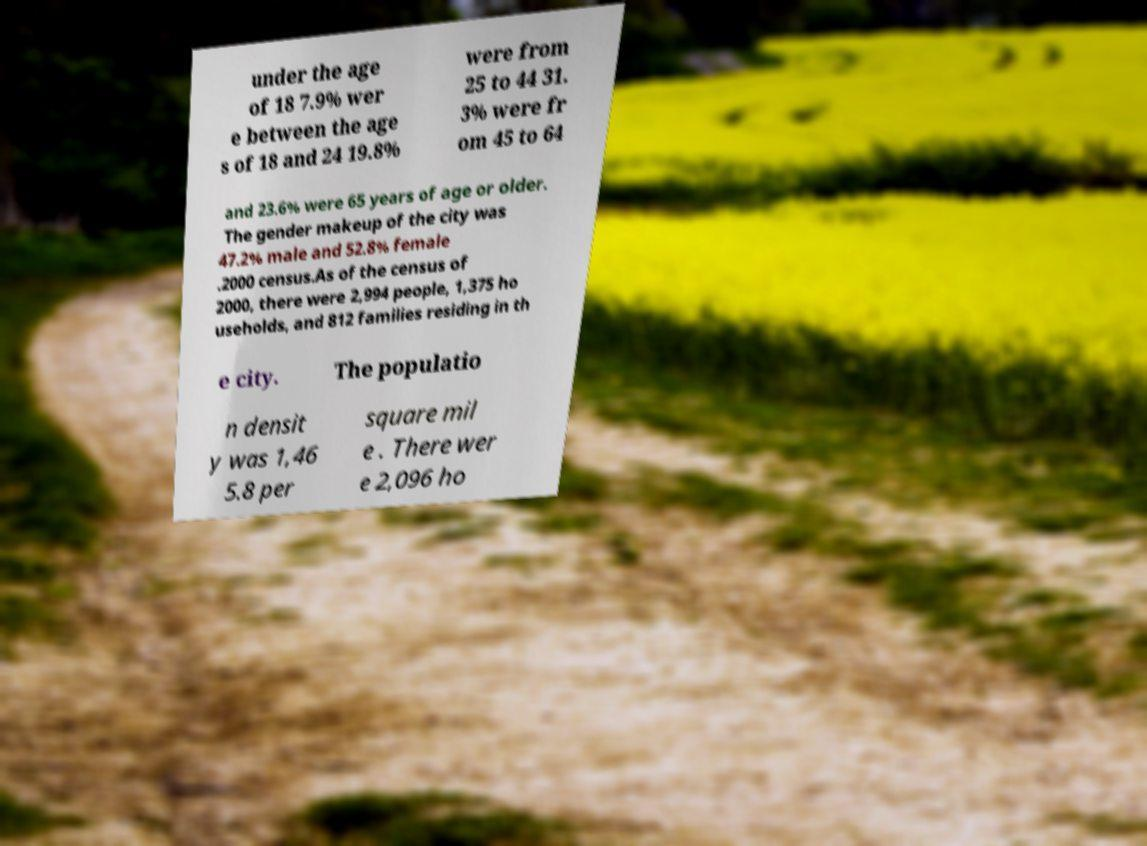There's text embedded in this image that I need extracted. Can you transcribe it verbatim? under the age of 18 7.9% wer e between the age s of 18 and 24 19.8% were from 25 to 44 31. 3% were fr om 45 to 64 and 23.6% were 65 years of age or older. The gender makeup of the city was 47.2% male and 52.8% female .2000 census.As of the census of 2000, there were 2,994 people, 1,375 ho useholds, and 812 families residing in th e city. The populatio n densit y was 1,46 5.8 per square mil e . There wer e 2,096 ho 